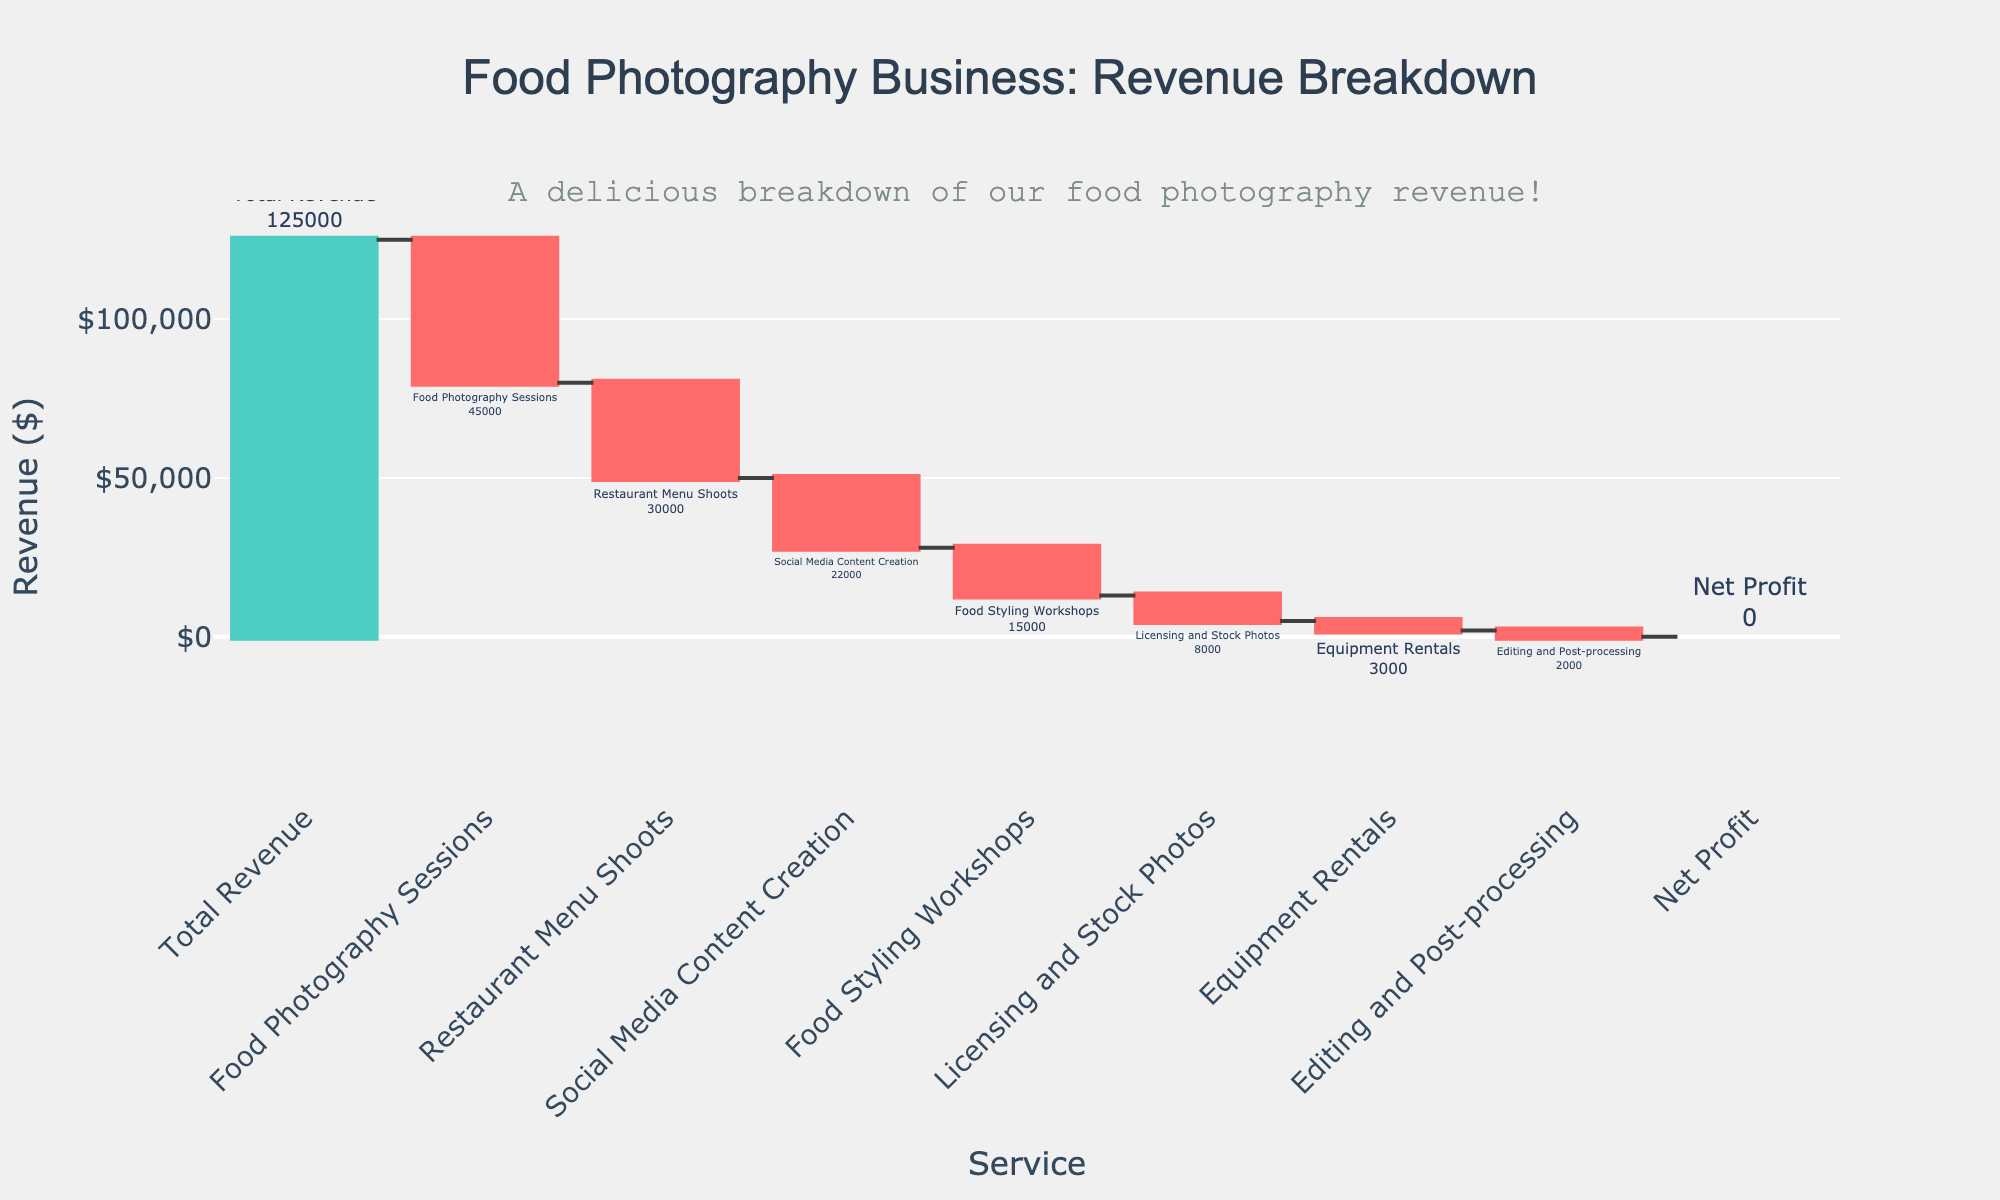What is the total revenue for the food photography business? The total revenue is listed clearly at the top of the chart. It is the sum of all services provided before deducting costs.
Answer: 125000 What service type has the highest negative impact on revenue? By observing the lengths of the red bars, the Food Photography Sessions bar is the longest, indicating the highest cost.
Answer: Food Photography Sessions How much revenue comes from Food Styling Workshops? The revenue from Food Styling Workshops is denoted by a red bar on the chart. The value associated with it is -15000.
Answer: -15000 What is the net profit after all revenue and costs are accounted for? The Net Profit is explicitly listed at the bottom of the waterfall chart as 0.
Answer: 0 How much more does Restaurant Menu Shoots reduce revenue compared to Licensing and Stock Photos? The revenue reduction from Restaurant Menu Shoots is -30000 and from Licensing and Stock Photos is -8000. The difference is 30000 - 8000.
Answer: 22000 What is the combined revenue reduction from Social Media Content Creation and Equipment Rentals? The revenue reductions are -22000 for Social Media Content Creation and -3000 for Equipment Rentals. The combined reduction is 22000 + 3000.
Answer: 25000 Which service type has the smallest negative revenue? Looking at the lengths of the red bars, the smallest would be Editing and Post-processing, with a value of -2000.
Answer: Editing and Post-processing How does the revenue from Social Media Content Creation compare to that from Food Photography Sessions? Social Media Content Creation has a revenue reduction of -22000, while Food Photography Sessions has -45000. Social Media Content Creation has a smaller negative impact than Food Photography Sessions.
Answer: Smaller negative impact If the revenue from Food Photography Sessions increased by 10000, what would be the new total revenue? Starting total revenue: 125000. Current loss from Food Photography Sessions is -45000. Increased revenue by 10000 would change the loss to -35000. New total revenue: 125000 + (45000 - 35000).
Answer: 135000 What percentage of the total revenue is impacted by the cost of Equipment Rentals? Total revenue is 125000, impact from Equipment Rentals is -3000. Percentage = (3000/125000) * 100%.
Answer: 2.4% 